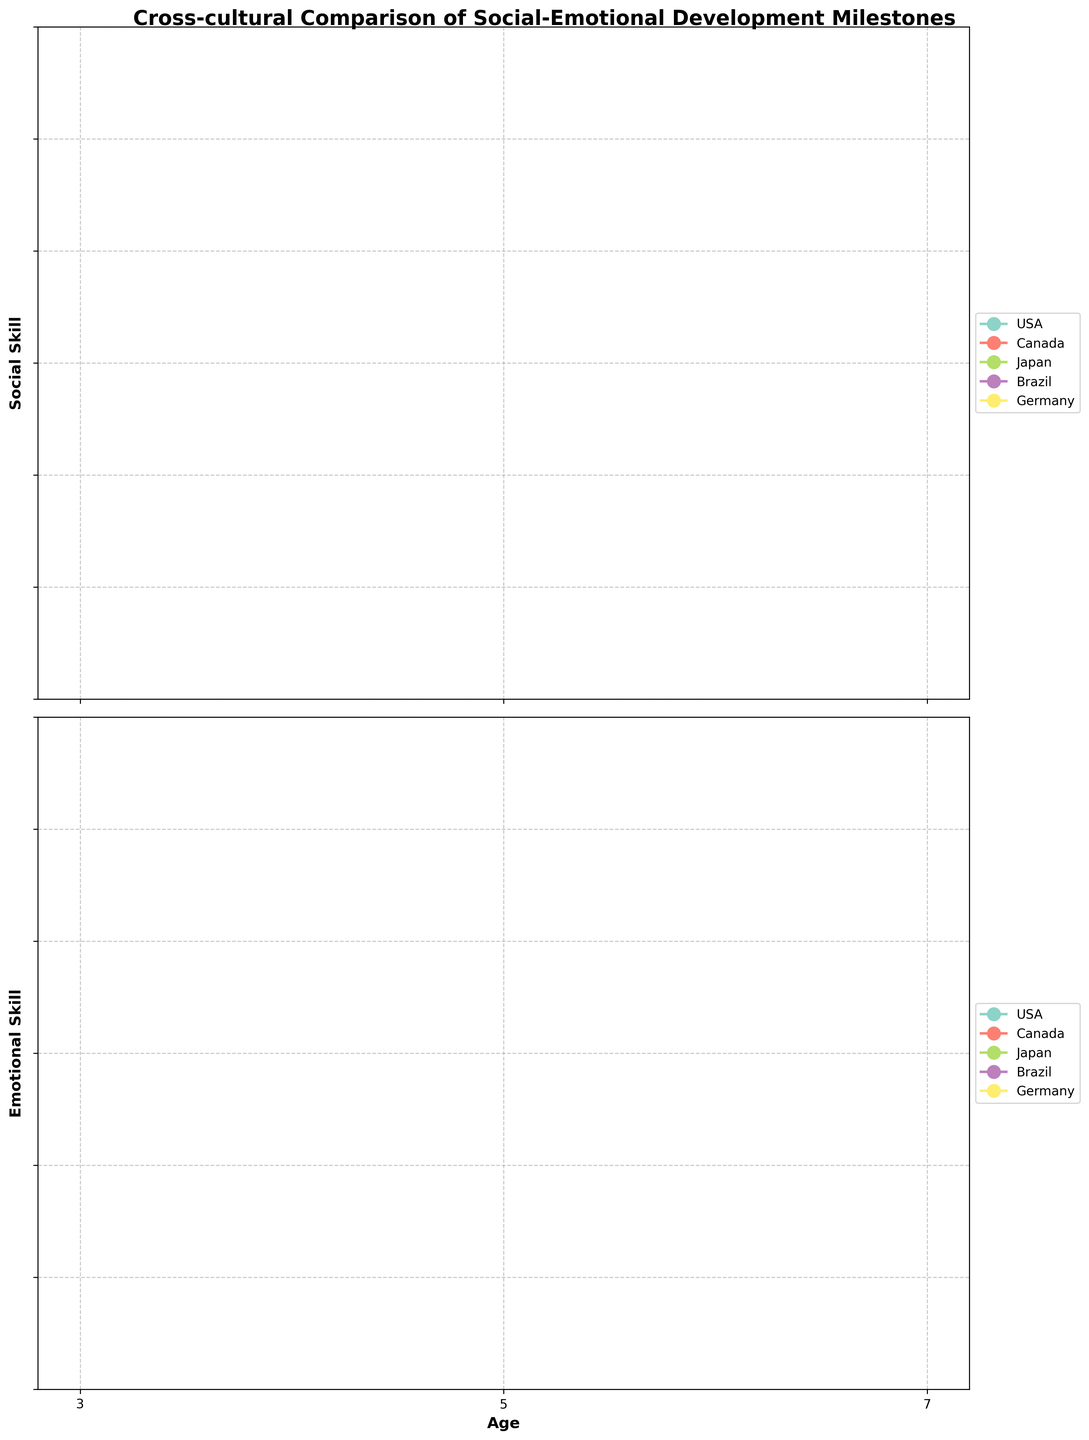What is the title of the figure? The title is usually placed at the top of the figure. It reads "Cross-cultural Comparison of Social-Emotional Development Milestones."
Answer: Cross-cultural Comparison of Social-Emotional Development Milestones Which country shows the highest overall social skill score for 7-year-olds? Looking at the "Social Skill" subplot, find the data points for 7-year-olds. Japan has the highest point at age 7 for Social Skill, with a value of 89.
Answer: Japan What are the social skills for 3-year-olds in Canada and what value is displayed for it? In the "Social Skill" subplot, locate the data for 3-year-olds in Canada. The value is 83 and the skill is Cooperative play.
Answer: Cooperative play, 83 Which age group in Brazil shows the highest emotional skill score? In the "Emotional Skill" subplot, find the data points for Brazil. Age 7 has the highest value at 92.
Answer: 7 Compare the social skill score for 5-year-olds between USA and Germany. Which country scored higher and by how much? For 5-year-olds in the "Social Skill" subplot, USA scored 90 and Germany scored 89. The USA scored higher by 1 point.
Answer: USA, 1 point What is the range of scores for emotional skills across countries for 5-year-olds? In the "Emotional Skill" subplot, find the data values for each country at age 5. The values are 91, 86, 84, 82, and 88. The range is 91 - 82.
Answer: 9 points Which country shows the most distinct pattern in the social skill scores across ages? By examining the "Social Skill" subplot, Japan stands out with a unique pattern of increasing sharply from age 3 to 7 compared to other countries.
Answer: Japan How does Canada's emotional skill at age 5 compare to its social skill at the same age? In the "Emotional Skill" subplot, Canada's score is 86 at age 5. In the "Social Skill" subplot, the score is 89 at the same age. The social skill is higher by 3 points.
Answer: Social skill is higher by 3 points 